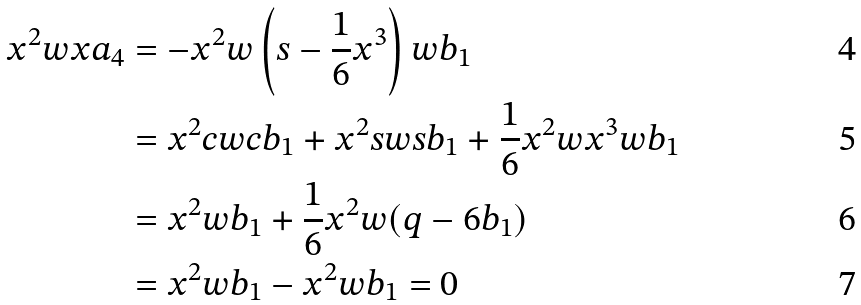<formula> <loc_0><loc_0><loc_500><loc_500>x ^ { 2 } w x a _ { 4 } & = - x ^ { 2 } w \left ( s - \frac { 1 } { 6 } x ^ { 3 } \right ) w b _ { 1 } \\ & = x ^ { 2 } c w c b _ { 1 } + x ^ { 2 } s w s b _ { 1 } + \frac { 1 } { 6 } x ^ { 2 } w x ^ { 3 } w b _ { 1 } \\ & = x ^ { 2 } w b _ { 1 } + \frac { 1 } { 6 } x ^ { 2 } w ( q - 6 b _ { 1 } ) \\ & = x ^ { 2 } w b _ { 1 } - x ^ { 2 } w b _ { 1 } = 0</formula> 